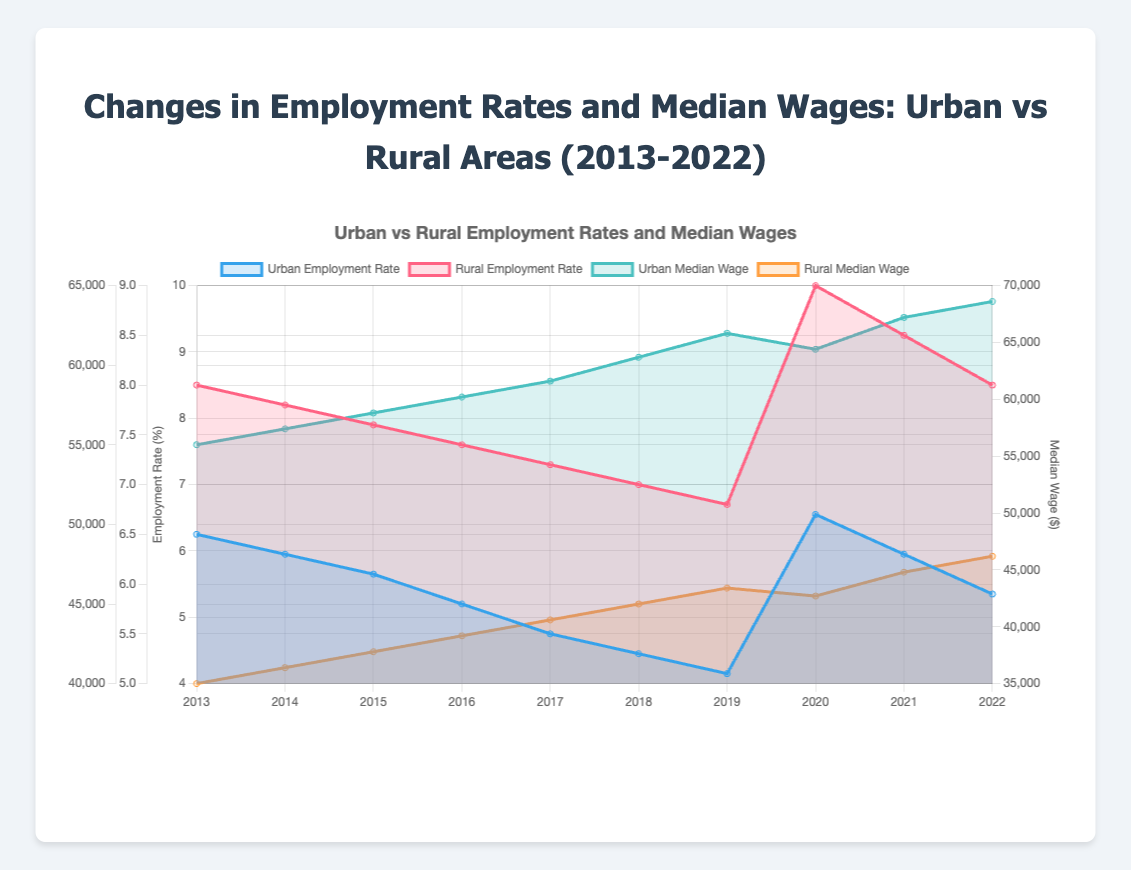What is the overall trend in the urban employment rate from 2013 to 2022? The urban employment rate generally shows a decreasing trend from 2013 to 2019, followed by an increase in 2020, before falling again in subsequent years.
Answer: Decreasing trend with some fluctuations How did the rural employment rate change in 2020 compared to 2019? In 2019, the rural employment rate was 6.8%, and it increased to 9.0% in 2020, indicating a rise.
Answer: Increased Between urban and rural areas, which had a higher median wage in 2014? The median wage in urban areas in 2014 was $56,000, while in rural areas it was $41,000. Therefore, urban areas had a higher median wage.
Answer: Urban areas What was the employment rate in rural areas in 2021? The employment rate in rural areas in 2021 was 8.5%.
Answer: 8.5% What is the difference between urban and rural median wages in 2022? The urban median wage in 2022 was $64,000 and the rural median wage was $48,000. The difference is $64,000 - $48,000 = $16,000.
Answer: $16,000 Which area has shown more variability in employment rates over the ten years? Rural areas show more variability in employment rates with a range from 6.8% to 9.0%, while urban areas range from 5.1% to 6.7%.
Answer: Rural areas How did the median wage in urban areas change from 2013 to 2018? The median wage in urban areas increased from $55,000 in 2013 to $60,500 in 2018.
Answer: Increased by $5,500 Which year had the highest employment rate in urban areas? The year 2020 had the highest employment rate in urban areas at 6.7%.
Answer: 2020 What is the average median wage for rural areas over the ten years? Sum up the median wages for rural areas from 2013 to 2022: 40000 + 41000 + 42000 + 43000 + 44000 + 45000 + 46000 + 45500 + 47000 + 48000 = 431500. Divide by 10 to get the average, which is 431500 / 10 = 43150.
Answer: $43,150 Is there a correlation between the urban median wage and employment rate? Over the ten years, as the urban employment rate tends to decrease, the median wage tends to increase. This inverse relationship suggests a negative correlation.
Answer: Negative correlation 